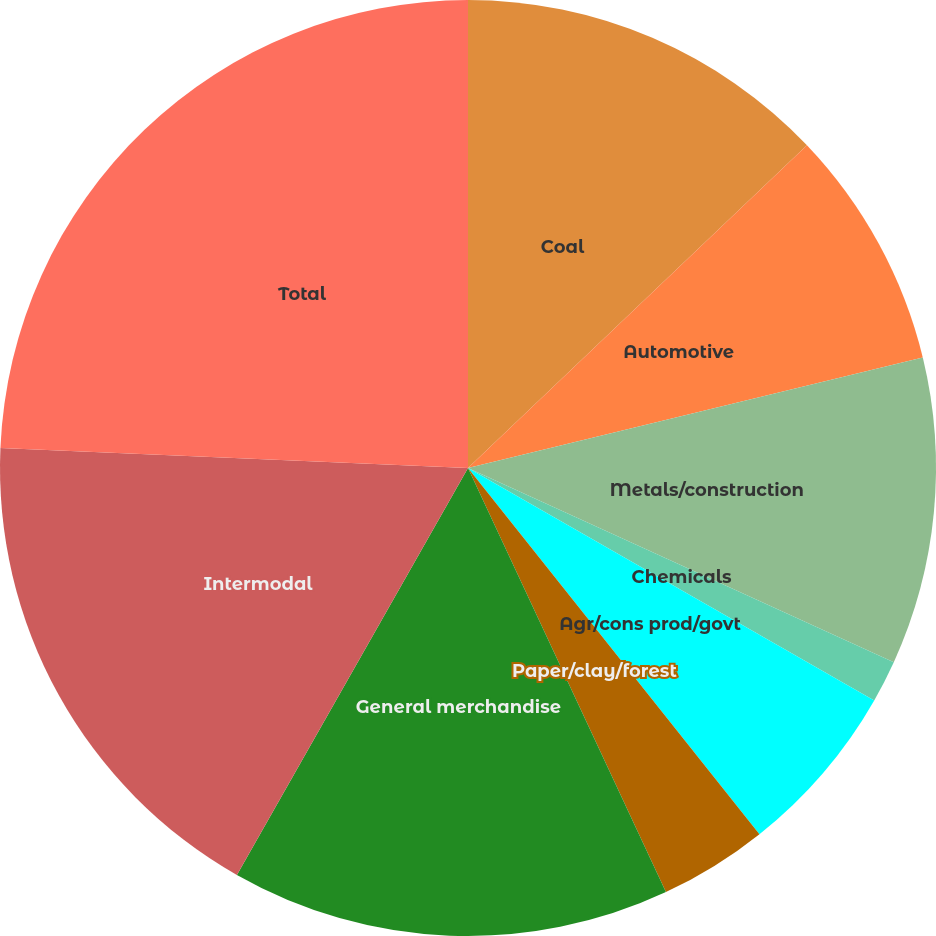Convert chart. <chart><loc_0><loc_0><loc_500><loc_500><pie_chart><fcel>Coal<fcel>Automotive<fcel>Metals/construction<fcel>Chemicals<fcel>Agr/cons prod/govt<fcel>Paper/clay/forest<fcel>General merchandise<fcel>Intermodal<fcel>Total<nl><fcel>12.89%<fcel>8.32%<fcel>10.6%<fcel>1.46%<fcel>6.03%<fcel>3.75%<fcel>15.17%<fcel>17.46%<fcel>24.32%<nl></chart> 